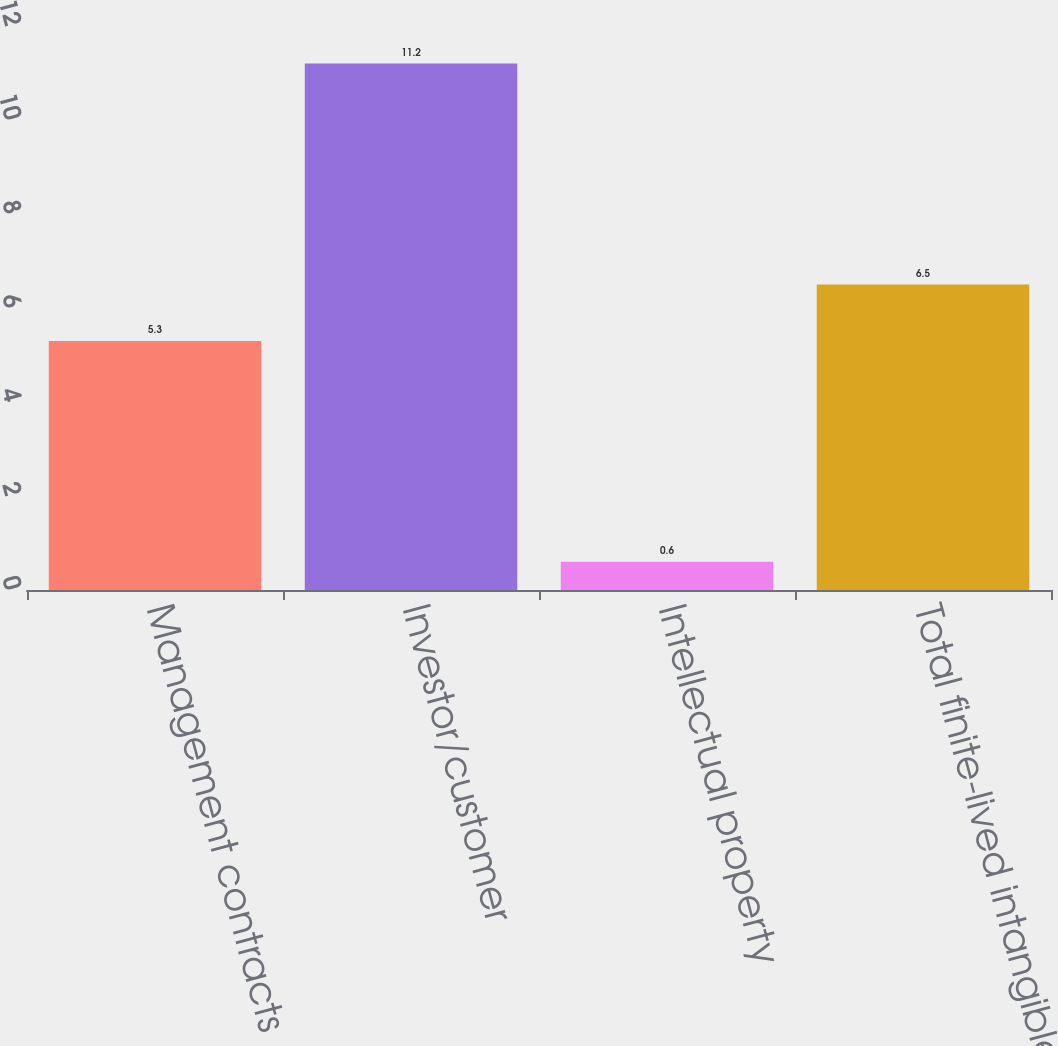Convert chart to OTSL. <chart><loc_0><loc_0><loc_500><loc_500><bar_chart><fcel>Management contracts<fcel>Investor/customer<fcel>Intellectual property<fcel>Total finite-lived intangible<nl><fcel>5.3<fcel>11.2<fcel>0.6<fcel>6.5<nl></chart> 